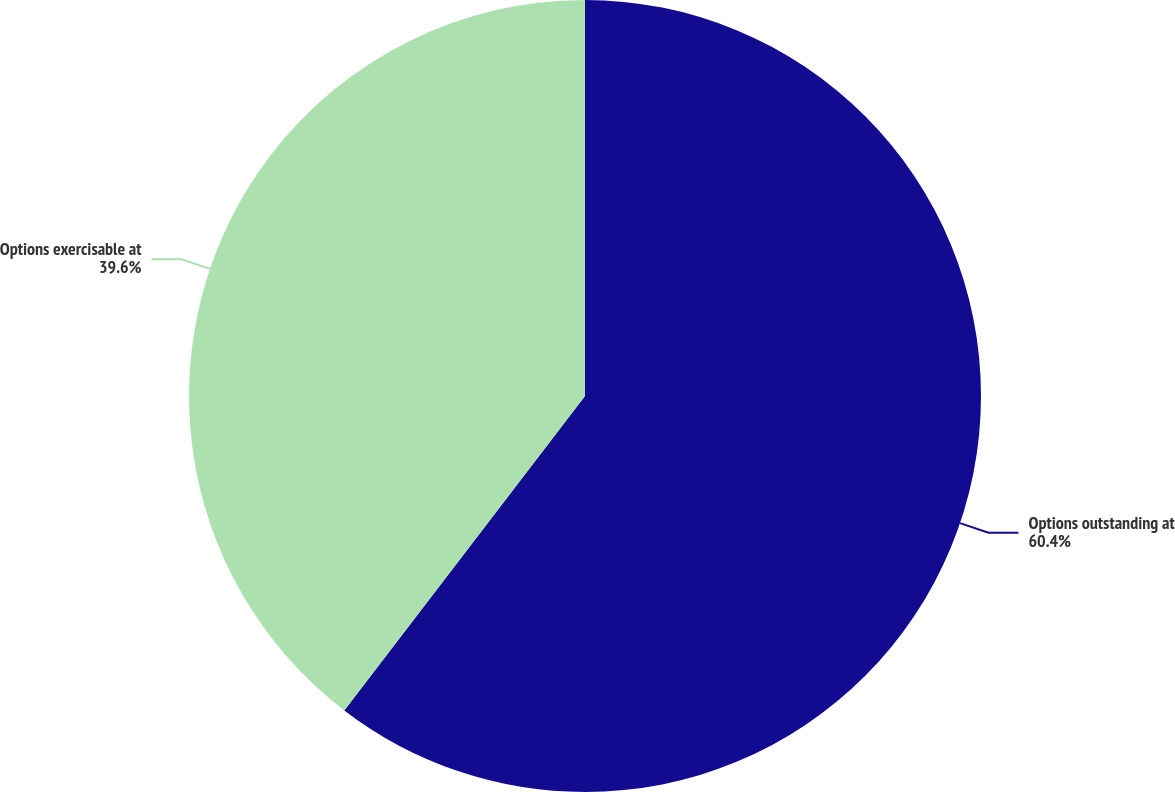<chart> <loc_0><loc_0><loc_500><loc_500><pie_chart><fcel>Options outstanding at<fcel>Options exercisable at<nl><fcel>60.4%<fcel>39.6%<nl></chart> 